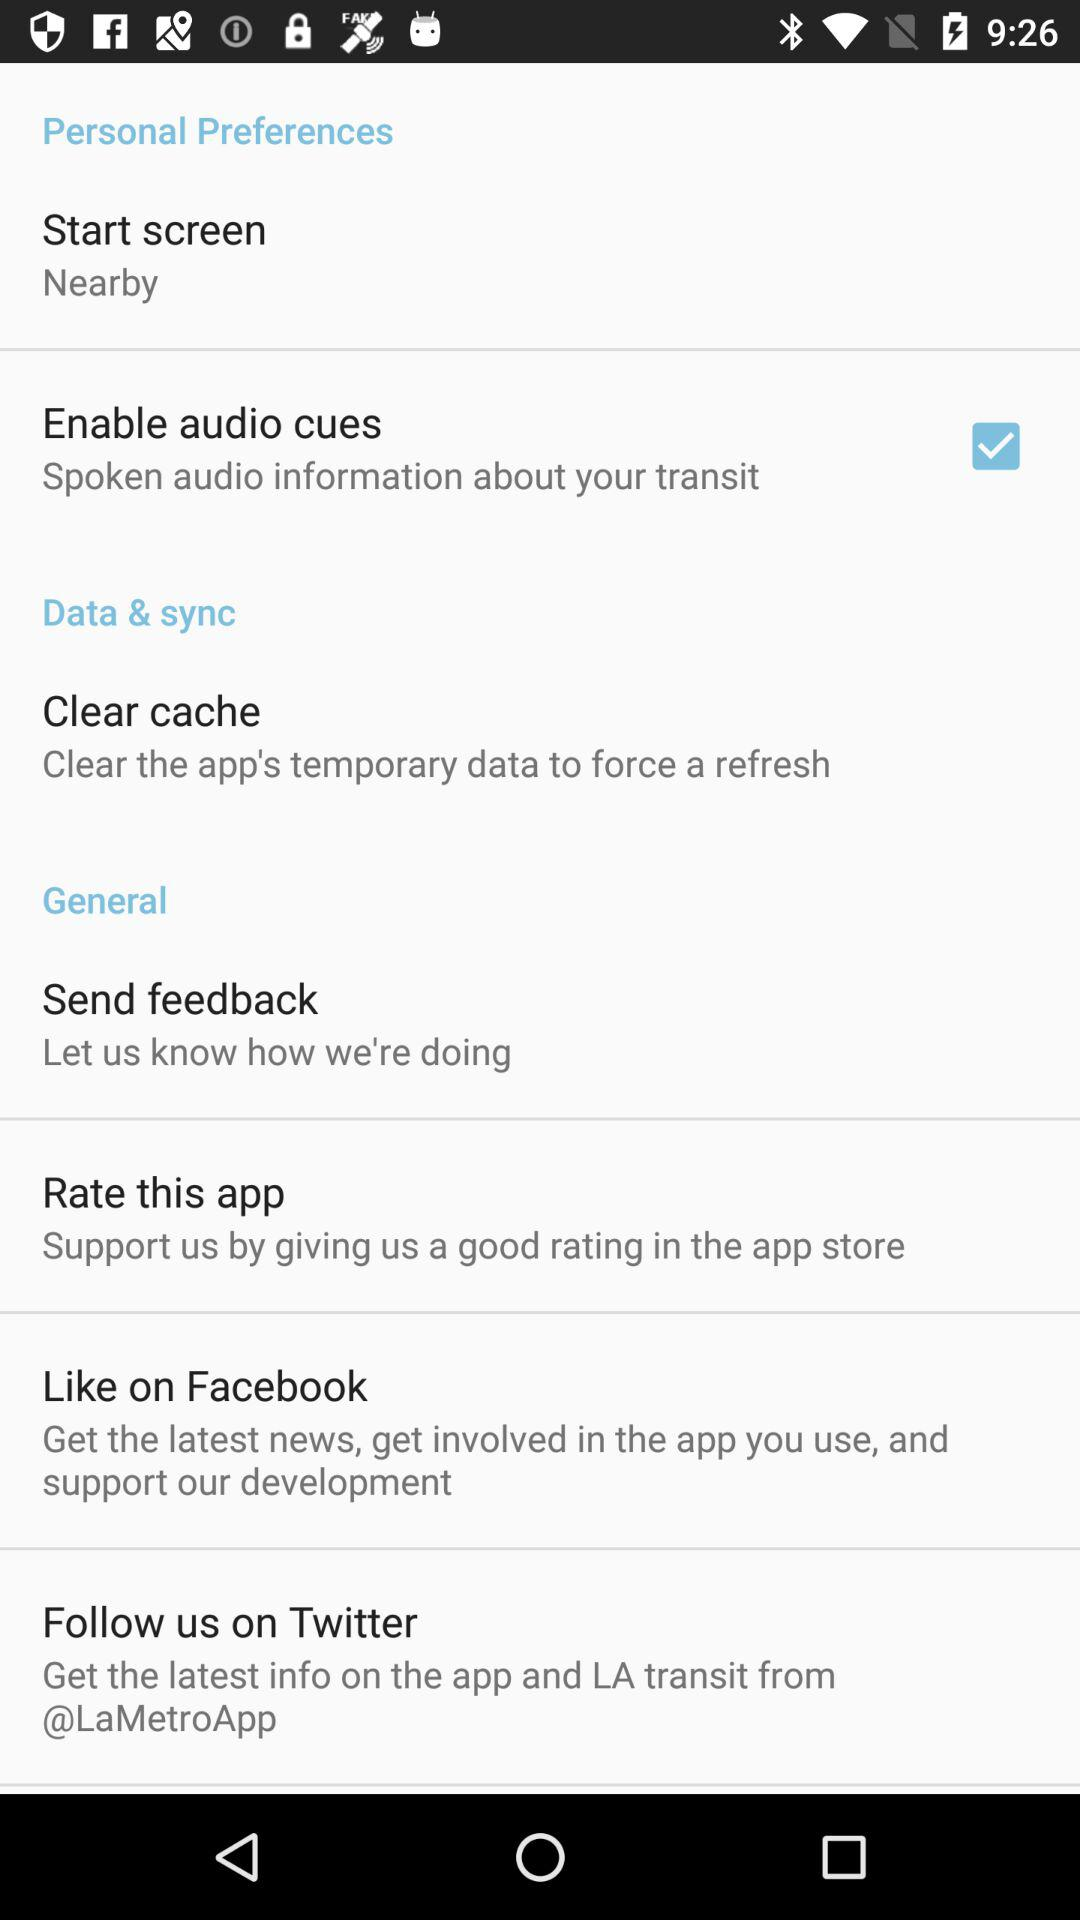What is the status of "Enable audio cues"? The status of "Enable audio cues" is "on". 